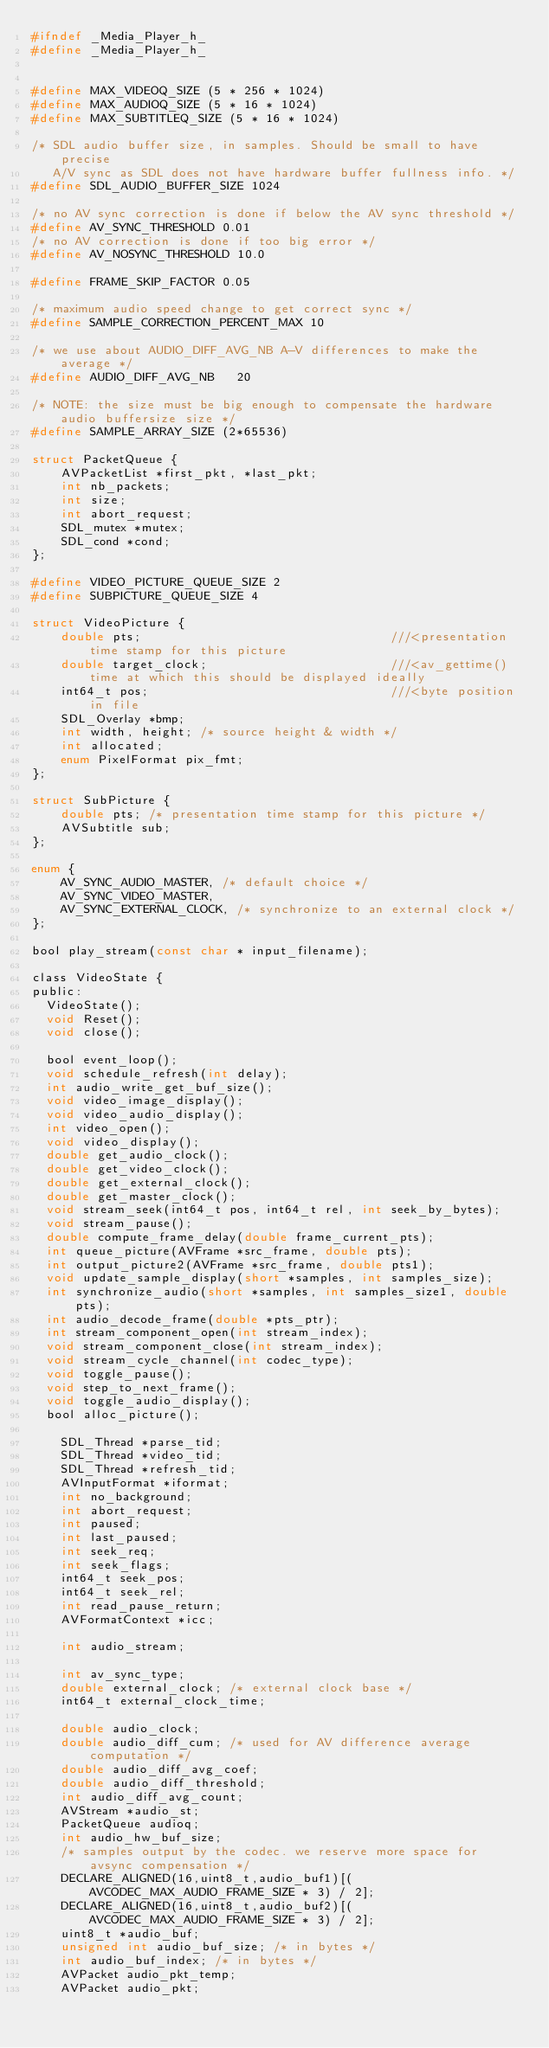<code> <loc_0><loc_0><loc_500><loc_500><_C_>#ifndef _Media_Player_h_
#define _Media_Player_h_


#define MAX_VIDEOQ_SIZE (5 * 256 * 1024)
#define MAX_AUDIOQ_SIZE (5 * 16 * 1024)
#define MAX_SUBTITLEQ_SIZE (5 * 16 * 1024)

/* SDL audio buffer size, in samples. Should be small to have precise
   A/V sync as SDL does not have hardware buffer fullness info. */
#define SDL_AUDIO_BUFFER_SIZE 1024

/* no AV sync correction is done if below the AV sync threshold */
#define AV_SYNC_THRESHOLD 0.01
/* no AV correction is done if too big error */
#define AV_NOSYNC_THRESHOLD 10.0

#define FRAME_SKIP_FACTOR 0.05

/* maximum audio speed change to get correct sync */
#define SAMPLE_CORRECTION_PERCENT_MAX 10

/* we use about AUDIO_DIFF_AVG_NB A-V differences to make the average */
#define AUDIO_DIFF_AVG_NB   20

/* NOTE: the size must be big enough to compensate the hardware audio buffersize size */
#define SAMPLE_ARRAY_SIZE (2*65536)

struct PacketQueue {
    AVPacketList *first_pkt, *last_pkt;
    int nb_packets;
    int size;
    int abort_request;
    SDL_mutex *mutex;
    SDL_cond *cond;
};

#define VIDEO_PICTURE_QUEUE_SIZE 2
#define SUBPICTURE_QUEUE_SIZE 4

struct VideoPicture {
    double pts;                                  ///<presentation time stamp for this picture
    double target_clock;                         ///<av_gettime() time at which this should be displayed ideally
    int64_t pos;                                 ///<byte position in file
    SDL_Overlay *bmp;
    int width, height; /* source height & width */
    int allocated;
    enum PixelFormat pix_fmt;
};

struct SubPicture {
    double pts; /* presentation time stamp for this picture */
    AVSubtitle sub;
};

enum {
    AV_SYNC_AUDIO_MASTER, /* default choice */
    AV_SYNC_VIDEO_MASTER,
    AV_SYNC_EXTERNAL_CLOCK, /* synchronize to an external clock */
};

bool play_stream(const char * input_filename);

class VideoState {
public:
	VideoState();
	void Reset();
	void close();
	
	bool event_loop();
	void schedule_refresh(int delay);
	int audio_write_get_buf_size();
	void video_image_display();
	void video_audio_display();
	int video_open();
	void video_display();
	double get_audio_clock();
	double get_video_clock();
	double get_external_clock();
	double get_master_clock();
	void stream_seek(int64_t pos, int64_t rel, int seek_by_bytes);
	void stream_pause();
	double compute_frame_delay(double frame_current_pts);
	int queue_picture(AVFrame *src_frame, double pts);
	int output_picture2(AVFrame *src_frame, double pts1);
	void update_sample_display(short *samples, int samples_size);
	int synchronize_audio(short *samples, int samples_size1, double pts);
	int audio_decode_frame(double *pts_ptr);
	int stream_component_open(int stream_index);
	void stream_component_close(int stream_index);
	void stream_cycle_channel(int codec_type);
	void toggle_pause();
	void step_to_next_frame();
	void toggle_audio_display();
	bool alloc_picture();

    SDL_Thread *parse_tid;
    SDL_Thread *video_tid;
    SDL_Thread *refresh_tid;
    AVInputFormat *iformat;
    int no_background;
    int abort_request;
    int paused;
    int last_paused;
    int seek_req;
    int seek_flags;
    int64_t seek_pos;
    int64_t seek_rel;
    int read_pause_return;
    AVFormatContext *icc;		

    int audio_stream;

    int av_sync_type;
    double external_clock; /* external clock base */
    int64_t external_clock_time;

    double audio_clock;
    double audio_diff_cum; /* used for AV difference average computation */
    double audio_diff_avg_coef;
    double audio_diff_threshold;
    int audio_diff_avg_count;
    AVStream *audio_st;
    PacketQueue audioq;
    int audio_hw_buf_size;
    /* samples output by the codec. we reserve more space for avsync compensation */
    DECLARE_ALIGNED(16,uint8_t,audio_buf1)[(AVCODEC_MAX_AUDIO_FRAME_SIZE * 3) / 2];
    DECLARE_ALIGNED(16,uint8_t,audio_buf2)[(AVCODEC_MAX_AUDIO_FRAME_SIZE * 3) / 2];
    uint8_t *audio_buf;
    unsigned int audio_buf_size; /* in bytes */
    int audio_buf_index; /* in bytes */
    AVPacket audio_pkt_temp;
    AVPacket audio_pkt;</code> 